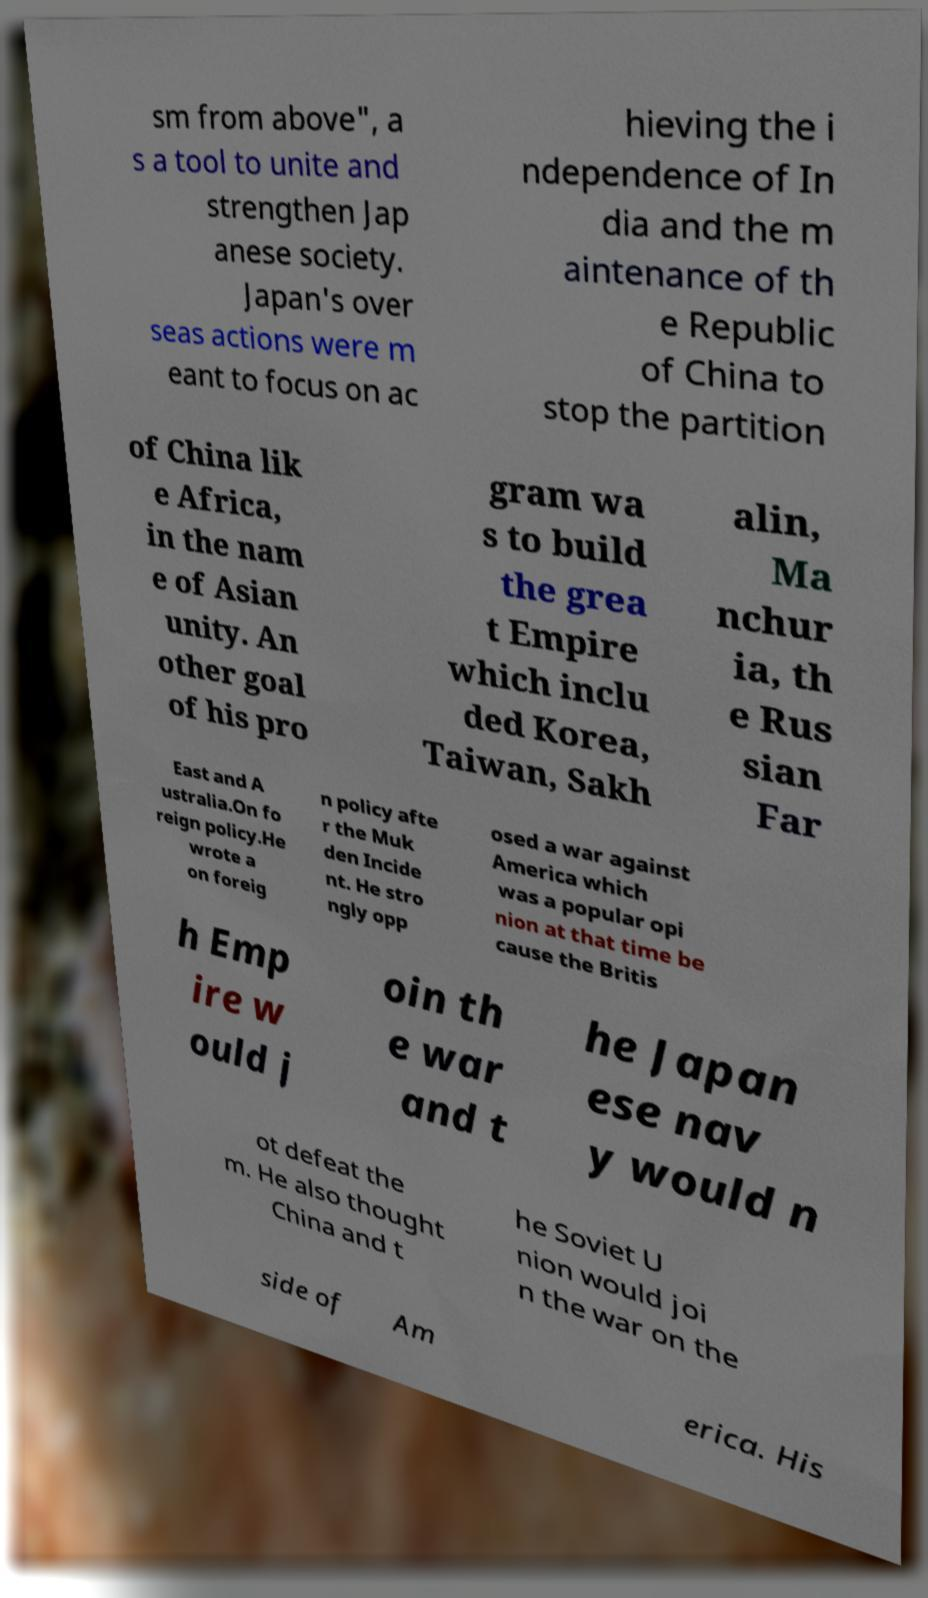What messages or text are displayed in this image? I need them in a readable, typed format. sm from above", a s a tool to unite and strengthen Jap anese society. Japan's over seas actions were m eant to focus on ac hieving the i ndependence of In dia and the m aintenance of th e Republic of China to stop the partition of China lik e Africa, in the nam e of Asian unity. An other goal of his pro gram wa s to build the grea t Empire which inclu ded Korea, Taiwan, Sakh alin, Ma nchur ia, th e Rus sian Far East and A ustralia.On fo reign policy.He wrote a on foreig n policy afte r the Muk den Incide nt. He stro ngly opp osed a war against America which was a popular opi nion at that time be cause the Britis h Emp ire w ould j oin th e war and t he Japan ese nav y would n ot defeat the m. He also thought China and t he Soviet U nion would joi n the war on the side of Am erica. His 